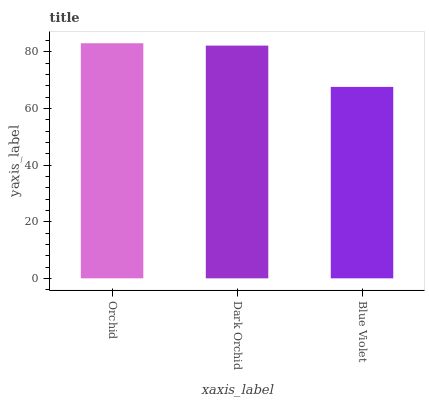Is Blue Violet the minimum?
Answer yes or no. Yes. Is Orchid the maximum?
Answer yes or no. Yes. Is Dark Orchid the minimum?
Answer yes or no. No. Is Dark Orchid the maximum?
Answer yes or no. No. Is Orchid greater than Dark Orchid?
Answer yes or no. Yes. Is Dark Orchid less than Orchid?
Answer yes or no. Yes. Is Dark Orchid greater than Orchid?
Answer yes or no. No. Is Orchid less than Dark Orchid?
Answer yes or no. No. Is Dark Orchid the high median?
Answer yes or no. Yes. Is Dark Orchid the low median?
Answer yes or no. Yes. Is Blue Violet the high median?
Answer yes or no. No. Is Orchid the low median?
Answer yes or no. No. 